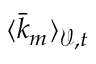<formula> <loc_0><loc_0><loc_500><loc_500>\langle \bar { k } _ { m } \rangle _ { \mathcal { V } , t }</formula> 